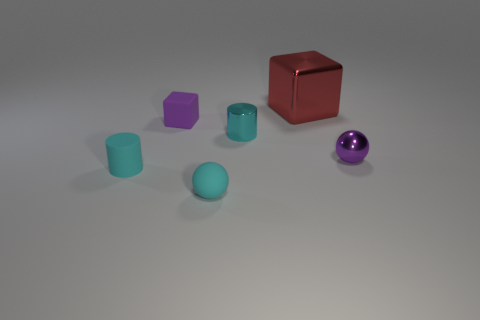How many cyan things are tiny metal objects or rubber blocks?
Ensure brevity in your answer.  1. Is the number of tiny shiny objects that are left of the red shiny block the same as the number of tiny red balls?
Offer a very short reply. No. How many things are red blocks or tiny cyan cylinders to the left of the cyan shiny thing?
Your answer should be compact. 2. Do the big thing and the small metal sphere have the same color?
Make the answer very short. No. Are there any cyan cylinders that have the same material as the tiny purple cube?
Offer a very short reply. Yes. What is the color of the rubber object that is the same shape as the small purple shiny object?
Offer a terse response. Cyan. Do the red object and the purple thing behind the metallic ball have the same material?
Keep it short and to the point. No. There is a purple object that is behind the cylinder on the right side of the tiny purple rubber thing; what is its shape?
Give a very brief answer. Cube. Does the cylinder that is behind the purple sphere have the same size as the cyan sphere?
Offer a very short reply. Yes. What number of other objects are there of the same shape as the red thing?
Keep it short and to the point. 1. 